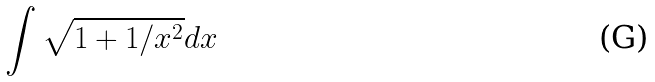Convert formula to latex. <formula><loc_0><loc_0><loc_500><loc_500>\int \sqrt { 1 + 1 / x ^ { 2 } } d x</formula> 